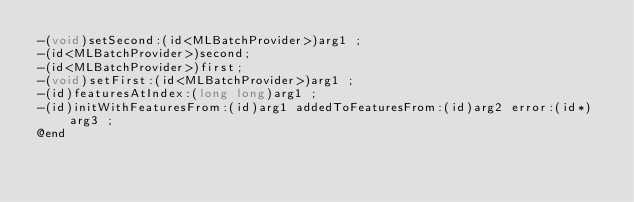<code> <loc_0><loc_0><loc_500><loc_500><_C_>-(void)setSecond:(id<MLBatchProvider>)arg1 ;
-(id<MLBatchProvider>)second;
-(id<MLBatchProvider>)first;
-(void)setFirst:(id<MLBatchProvider>)arg1 ;
-(id)featuresAtIndex:(long long)arg1 ;
-(id)initWithFeaturesFrom:(id)arg1 addedToFeaturesFrom:(id)arg2 error:(id*)arg3 ;
@end

</code> 